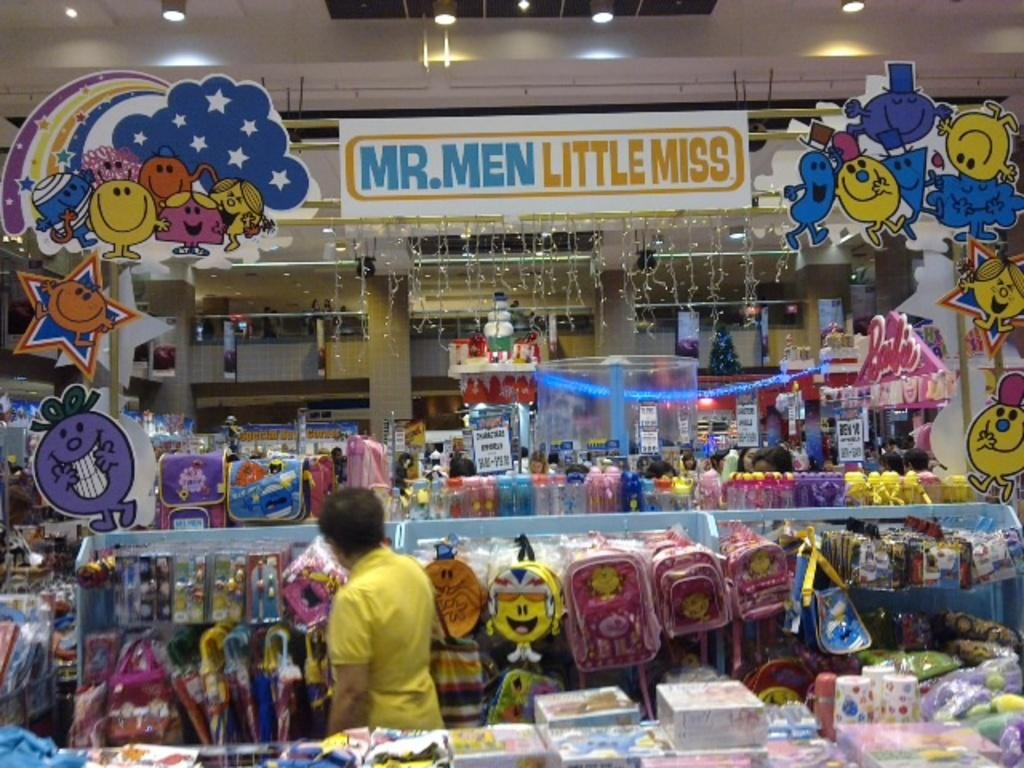<image>
Relay a brief, clear account of the picture shown. Store display of Mr. Men Little Miss Design Logos and Backpacks. 